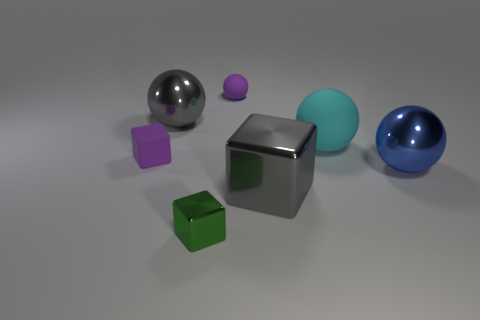There is a big object that is to the left of the big cyan object and to the right of the tiny sphere; what is its material?
Make the answer very short. Metal. Does the metallic sphere that is left of the blue metallic ball have the same color as the tiny object that is left of the green block?
Offer a terse response. No. How many other things are there of the same size as the cyan ball?
Keep it short and to the point. 3. There is a purple object that is on the right side of the small object to the left of the green metal thing; are there any metal balls that are to the right of it?
Offer a very short reply. Yes. Are the gray object that is in front of the big cyan rubber thing and the large gray sphere made of the same material?
Your answer should be very brief. Yes. There is a tiny object that is the same shape as the big matte object; what color is it?
Give a very brief answer. Purple. Are there the same number of big blue balls behind the large rubber thing and brown shiny spheres?
Provide a succinct answer. Yes. There is a gray metallic cube; are there any large objects behind it?
Your answer should be compact. Yes. There is a cyan matte object that is on the right side of the small purple thing that is in front of the big sphere that is on the left side of the cyan rubber object; what is its size?
Your answer should be compact. Large. There is a metal thing that is behind the small purple block; does it have the same shape as the big thing that is in front of the blue thing?
Offer a terse response. No. 